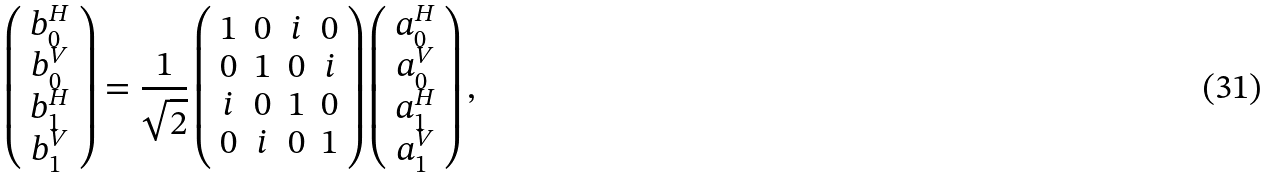<formula> <loc_0><loc_0><loc_500><loc_500>\left ( \begin{array} { c } b _ { 0 } ^ { H } \\ b _ { 0 } ^ { V } \\ b _ { 1 } ^ { H } \\ b _ { 1 } ^ { V } \end{array} \right ) = \frac { 1 } { \sqrt { 2 } } \left ( \begin{array} { c c c c } 1 & 0 & i & 0 \\ 0 & 1 & 0 & i \\ i & 0 & 1 & 0 \\ 0 & i & 0 & 1 \end{array} \right ) \left ( \begin{array} { c } a _ { 0 } ^ { H } \\ a _ { 0 } ^ { V } \\ a _ { 1 } ^ { H } \\ a _ { 1 } ^ { V } \end{array} \right ) ,</formula> 